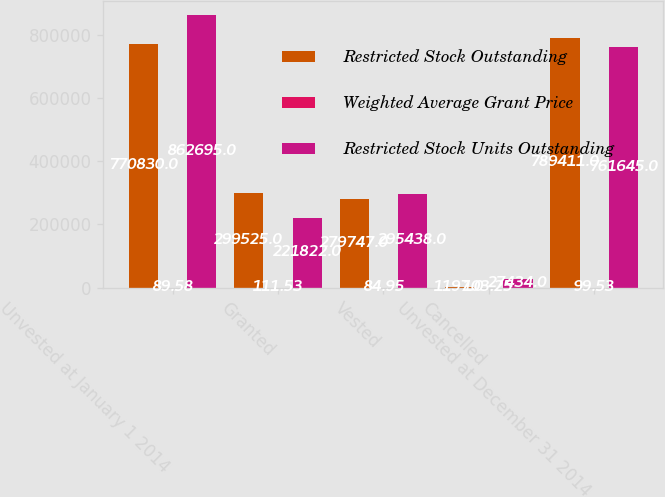<chart> <loc_0><loc_0><loc_500><loc_500><stacked_bar_chart><ecel><fcel>Unvested at January 1 2014<fcel>Granted<fcel>Vested<fcel>Cancelled<fcel>Unvested at December 31 2014<nl><fcel>Restricted Stock Outstanding<fcel>770830<fcel>299525<fcel>279747<fcel>1197<fcel>789411<nl><fcel>Weighted Average Grant Price<fcel>89.58<fcel>111.53<fcel>84.95<fcel>103.25<fcel>99.53<nl><fcel>Restricted Stock Units Outstanding<fcel>862695<fcel>221822<fcel>295438<fcel>27434<fcel>761645<nl></chart> 